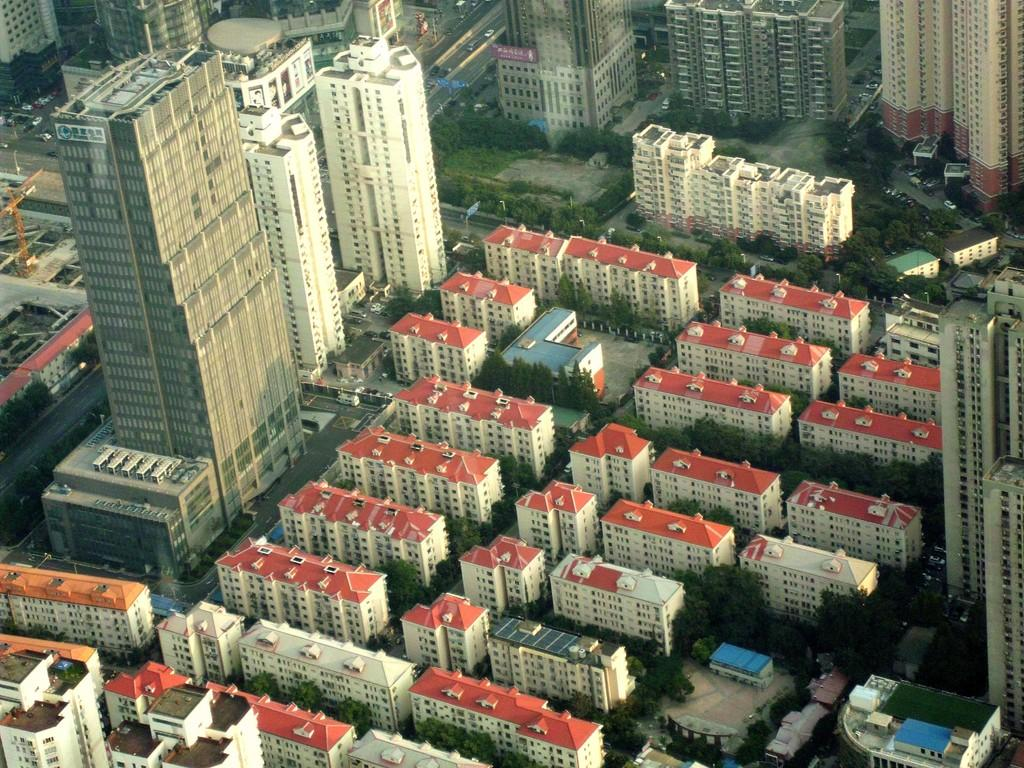What type of view is shown in the image? The image is an aerial view. What structures can be seen in the image? There are buildings, towers, and roofs visible in the image. What type of vegetation is present in the image? There are trees in the image. What type of transportation infrastructure is visible in the image? There is a road in the image, and vehicles can be seen on it. What type of toys are scattered on the roofs in the image? There are no toys visible in the image; only buildings, towers, roofs, trees, roads, and vehicles can be seen. 